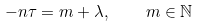Convert formula to latex. <formula><loc_0><loc_0><loc_500><loc_500>- n \tau = m + \lambda , \quad m \in \mathbb { N }</formula> 